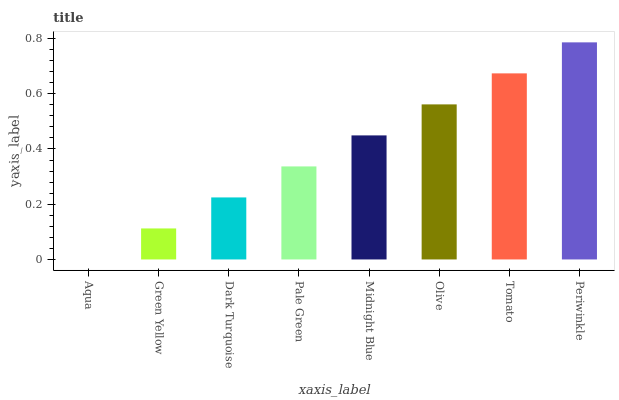Is Aqua the minimum?
Answer yes or no. Yes. Is Periwinkle the maximum?
Answer yes or no. Yes. Is Green Yellow the minimum?
Answer yes or no. No. Is Green Yellow the maximum?
Answer yes or no. No. Is Green Yellow greater than Aqua?
Answer yes or no. Yes. Is Aqua less than Green Yellow?
Answer yes or no. Yes. Is Aqua greater than Green Yellow?
Answer yes or no. No. Is Green Yellow less than Aqua?
Answer yes or no. No. Is Midnight Blue the high median?
Answer yes or no. Yes. Is Pale Green the low median?
Answer yes or no. Yes. Is Pale Green the high median?
Answer yes or no. No. Is Olive the low median?
Answer yes or no. No. 